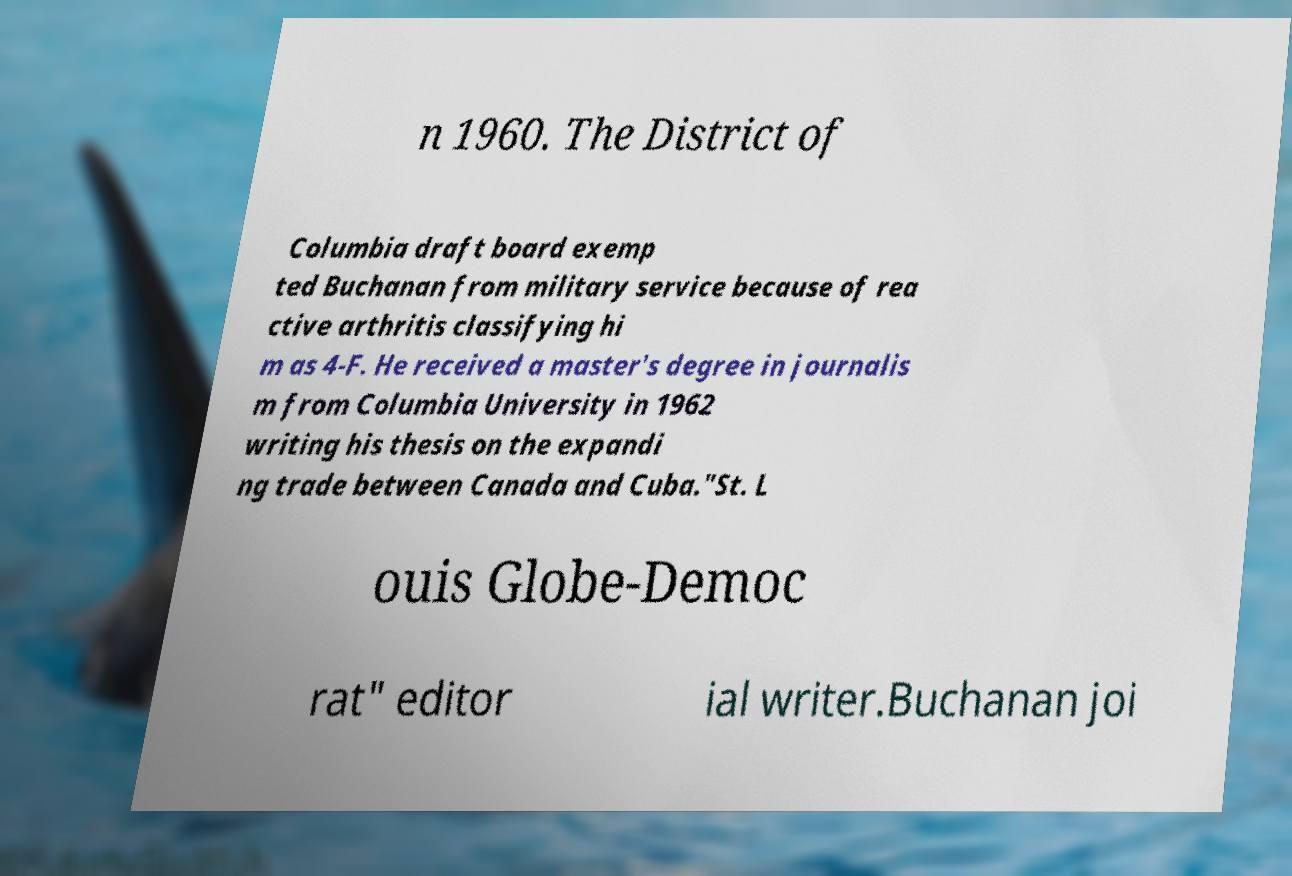Please identify and transcribe the text found in this image. n 1960. The District of Columbia draft board exemp ted Buchanan from military service because of rea ctive arthritis classifying hi m as 4-F. He received a master's degree in journalis m from Columbia University in 1962 writing his thesis on the expandi ng trade between Canada and Cuba."St. L ouis Globe-Democ rat" editor ial writer.Buchanan joi 